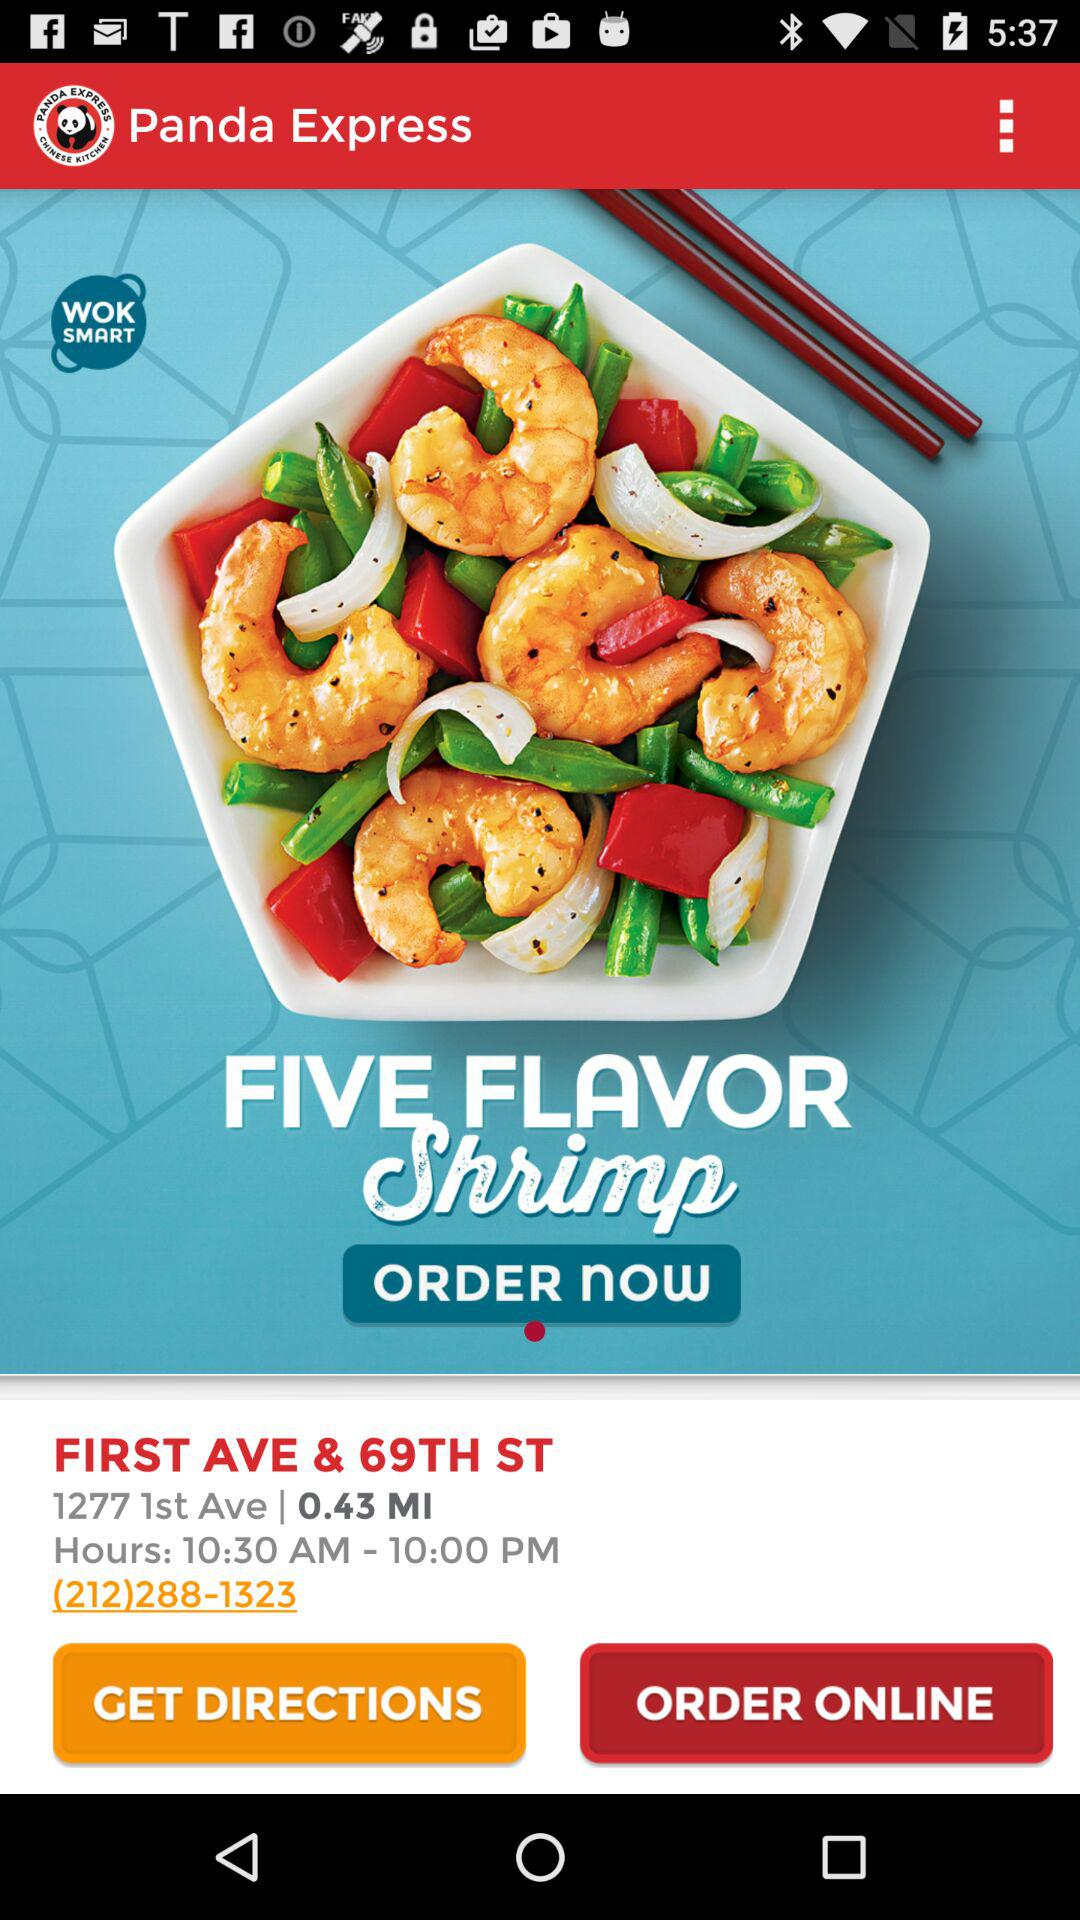What is the contact number to order? The contact number to order is (212)288-1323. 